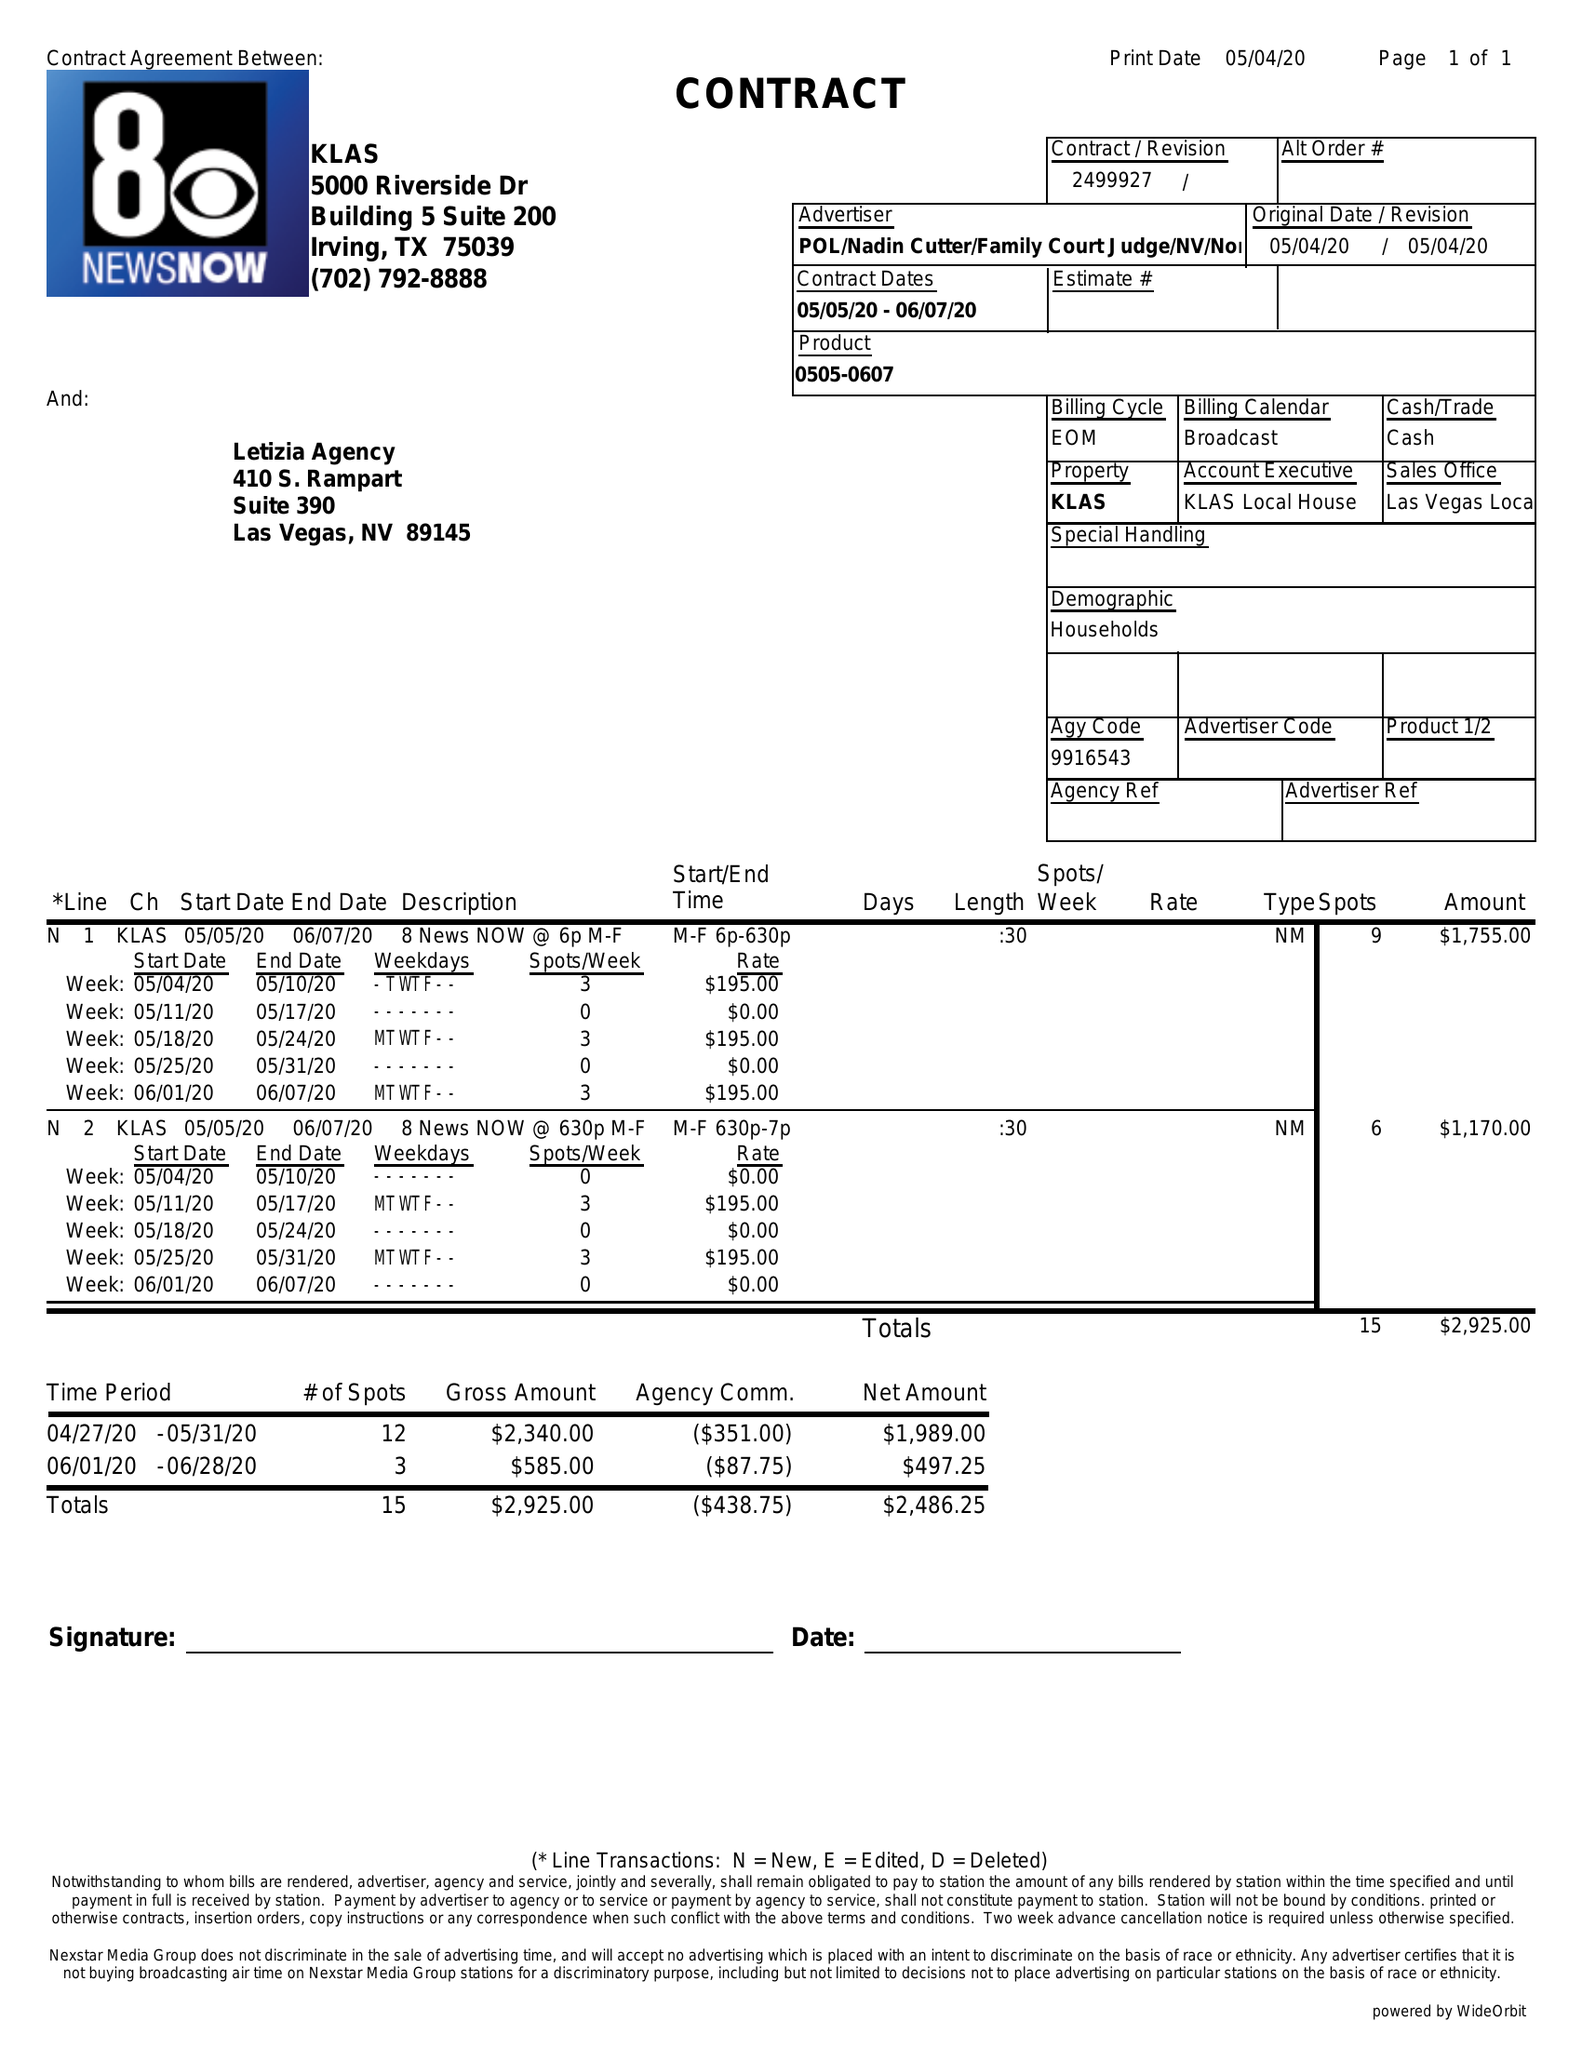What is the value for the flight_from?
Answer the question using a single word or phrase. 05/05/20 